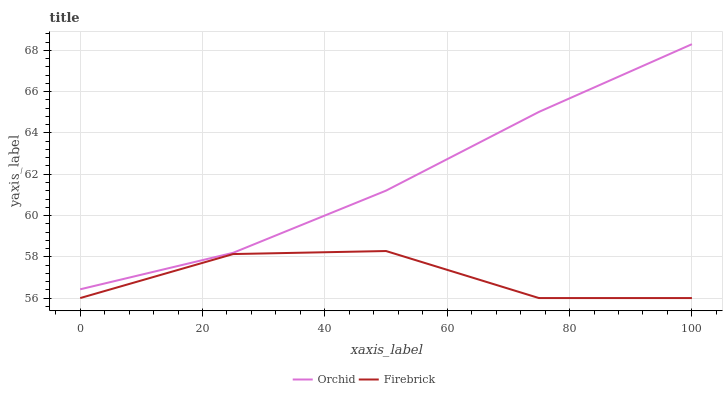Does Firebrick have the minimum area under the curve?
Answer yes or no. Yes. Does Orchid have the maximum area under the curve?
Answer yes or no. Yes. Does Orchid have the minimum area under the curve?
Answer yes or no. No. Is Orchid the smoothest?
Answer yes or no. Yes. Is Firebrick the roughest?
Answer yes or no. Yes. Is Orchid the roughest?
Answer yes or no. No. Does Firebrick have the lowest value?
Answer yes or no. Yes. Does Orchid have the lowest value?
Answer yes or no. No. Does Orchid have the highest value?
Answer yes or no. Yes. Is Firebrick less than Orchid?
Answer yes or no. Yes. Is Orchid greater than Firebrick?
Answer yes or no. Yes. Does Firebrick intersect Orchid?
Answer yes or no. No. 